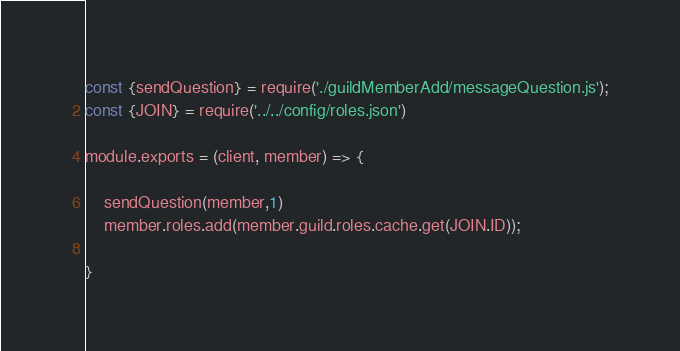<code> <loc_0><loc_0><loc_500><loc_500><_JavaScript_>const {sendQuestion} = require('./guildMemberAdd/messageQuestion.js');
const {JOIN} = require('../../config/roles.json')

module.exports = (client, member) => {

    sendQuestion(member,1)
    member.roles.add(member.guild.roles.cache.get(JOIN.ID));
    
}
</code> 